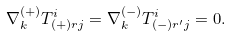Convert formula to latex. <formula><loc_0><loc_0><loc_500><loc_500>\nabla _ { k } ^ { ( + ) } T _ { ( + ) r j } ^ { i } = \nabla _ { k } ^ { ( - ) } T _ { ( - ) r ^ { \prime } j } ^ { i } = 0 .</formula> 